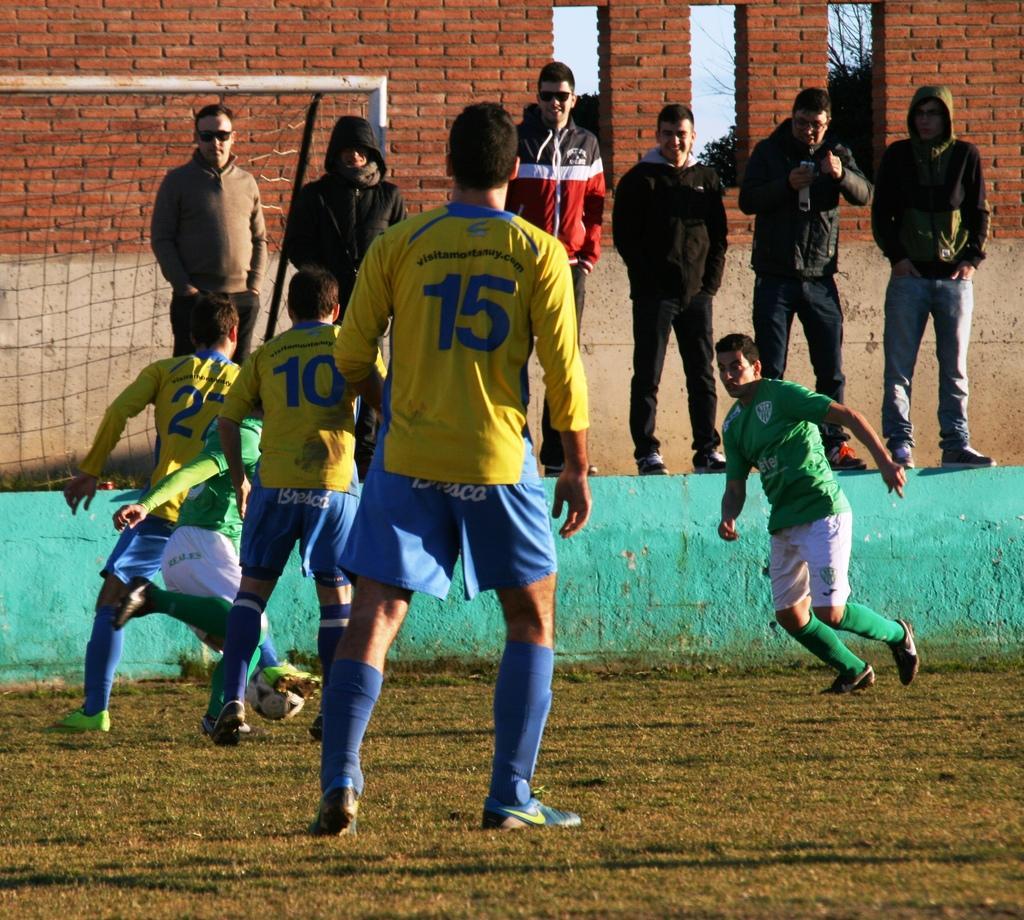How would you summarize this image in a sentence or two? In this image on the background there are group of people who are standing. In the foreground there are four persons who are walking towards ball. On the right side there is one man who is running on the background there is a brick wall and on the left side there is one fence and in the bottom there is grass. 